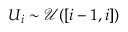<formula> <loc_0><loc_0><loc_500><loc_500>U _ { i } \sim \mathcal { U } ( [ i - 1 , i ] )</formula> 